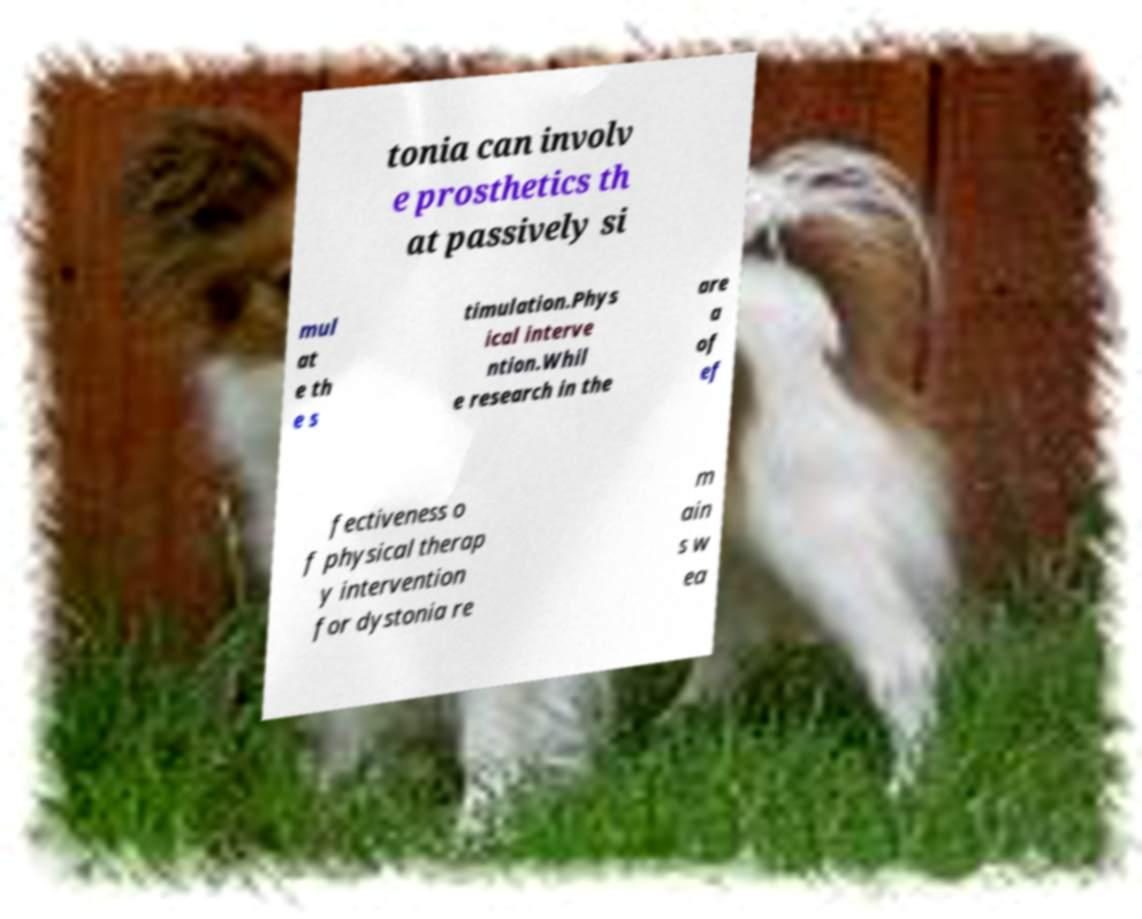Can you accurately transcribe the text from the provided image for me? tonia can involv e prosthetics th at passively si mul at e th e s timulation.Phys ical interve ntion.Whil e research in the are a of ef fectiveness o f physical therap y intervention for dystonia re m ain s w ea 